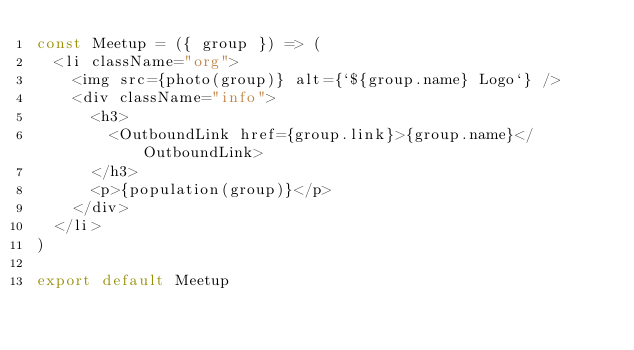<code> <loc_0><loc_0><loc_500><loc_500><_JavaScript_>const Meetup = ({ group }) => (
  <li className="org">
    <img src={photo(group)} alt={`${group.name} Logo`} />
    <div className="info">
      <h3>
        <OutboundLink href={group.link}>{group.name}</OutboundLink>
      </h3>
      <p>{population(group)}</p>
    </div>
  </li>
)

export default Meetup
</code> 